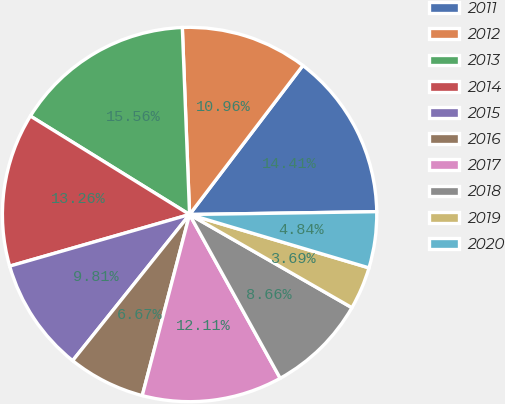<chart> <loc_0><loc_0><loc_500><loc_500><pie_chart><fcel>2011<fcel>2012<fcel>2013<fcel>2014<fcel>2015<fcel>2016<fcel>2017<fcel>2018<fcel>2019<fcel>2020<nl><fcel>14.41%<fcel>10.96%<fcel>15.56%<fcel>13.26%<fcel>9.81%<fcel>6.67%<fcel>12.11%<fcel>8.66%<fcel>3.69%<fcel>4.84%<nl></chart> 